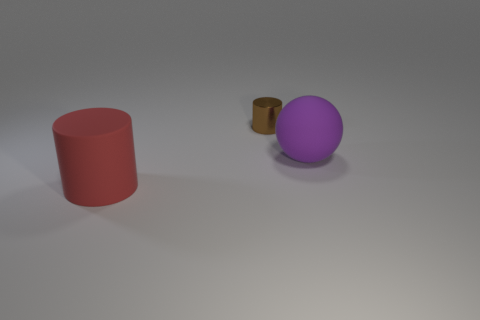Add 3 rubber things. How many objects exist? 6 Subtract 0 red blocks. How many objects are left? 3 Subtract all cylinders. How many objects are left? 1 Subtract all brown balls. Subtract all red cylinders. How many balls are left? 1 Subtract all tiny gray metallic things. Subtract all big objects. How many objects are left? 1 Add 1 tiny brown shiny things. How many tiny brown shiny things are left? 2 Add 2 purple balls. How many purple balls exist? 3 